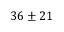<formula> <loc_0><loc_0><loc_500><loc_500>3 6 \pm 2 1</formula> 